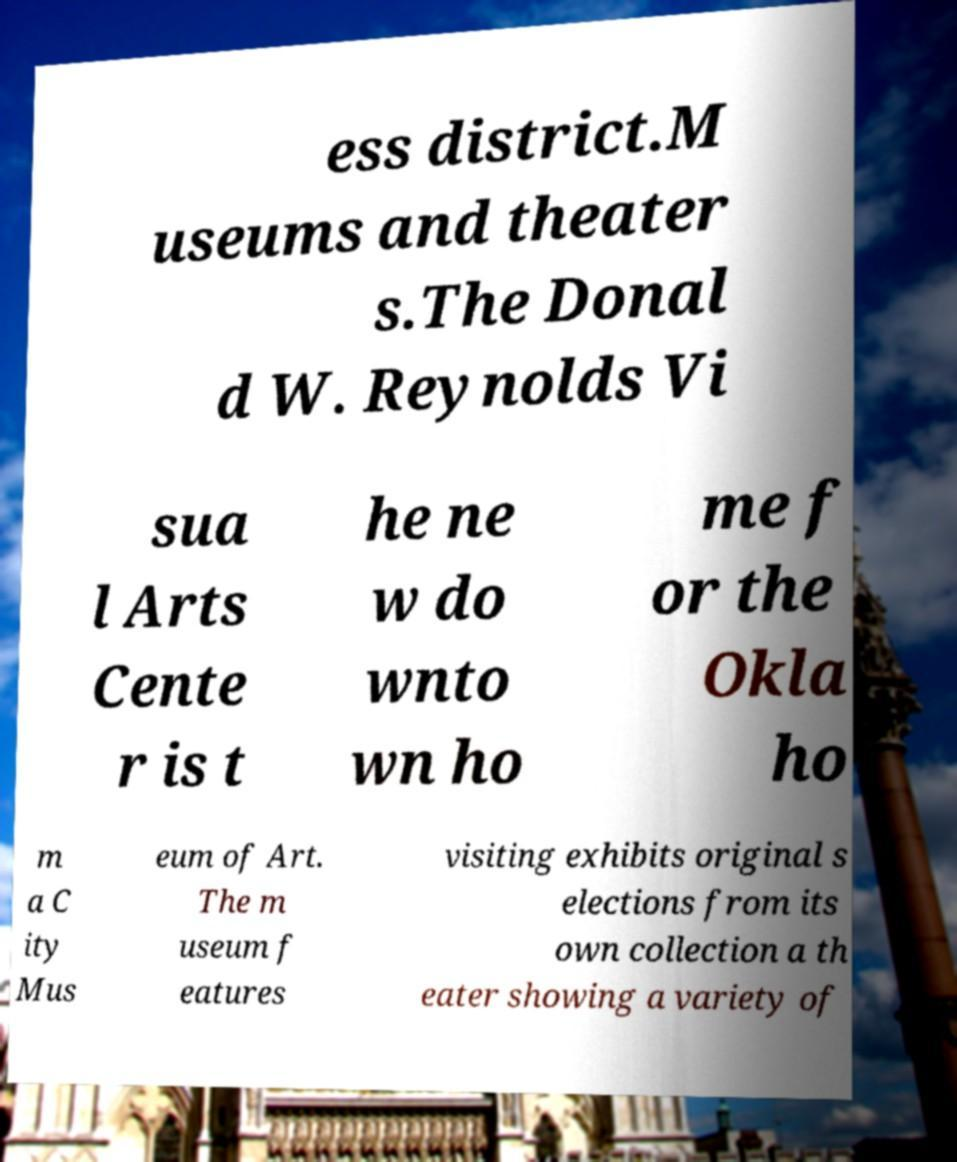I need the written content from this picture converted into text. Can you do that? ess district.M useums and theater s.The Donal d W. Reynolds Vi sua l Arts Cente r is t he ne w do wnto wn ho me f or the Okla ho m a C ity Mus eum of Art. The m useum f eatures visiting exhibits original s elections from its own collection a th eater showing a variety of 